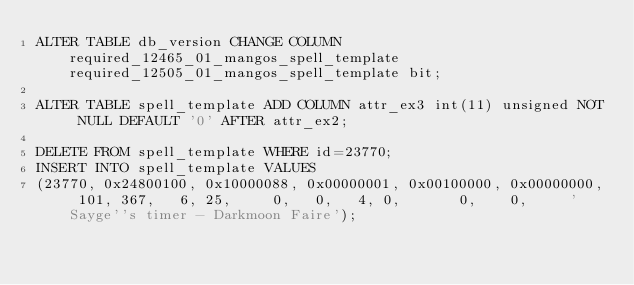<code> <loc_0><loc_0><loc_500><loc_500><_SQL_>ALTER TABLE db_version CHANGE COLUMN required_12465_01_mangos_spell_template required_12505_01_mangos_spell_template bit;

ALTER TABLE spell_template ADD COLUMN attr_ex3 int(11) unsigned NOT NULL DEFAULT '0' AFTER attr_ex2;

DELETE FROM spell_template WHERE id=23770;
INSERT INTO spell_template VALUES
(23770, 0x24800100, 0x10000088, 0x00000001, 0x00100000, 0x00000000, 101, 367,   6, 25,     0,   0,   4, 0,       0,    0,     'Sayge''s timer - Darkmoon Faire');
</code> 